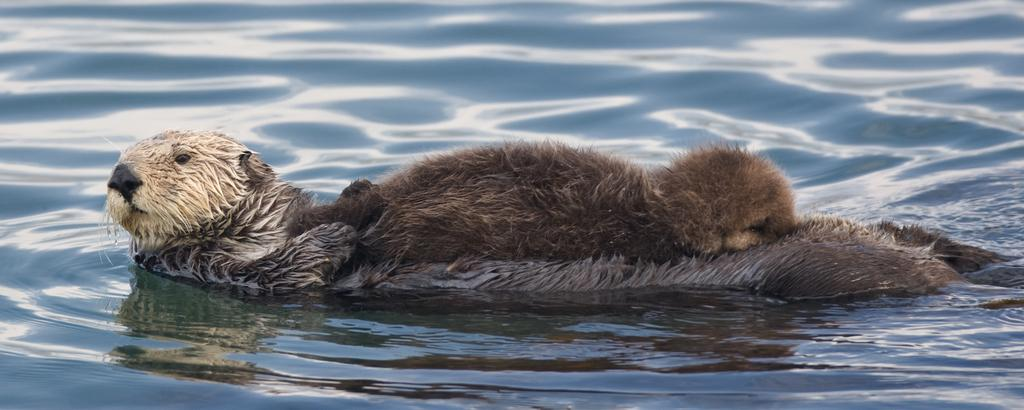What is the main subject of the image? There is an animal in the water in the image. Can you describe the animal's location in the image? The animal is in the water. What type of environment is depicted in the image? The image shows a water environment. What type of minister is conducting a dinner service in the image? There is no minister or dinner service present in the image; it features an animal in the water. What type of cup is being used by the animal in the image? There is no cup present in the image; it only shows an animal in the water. 